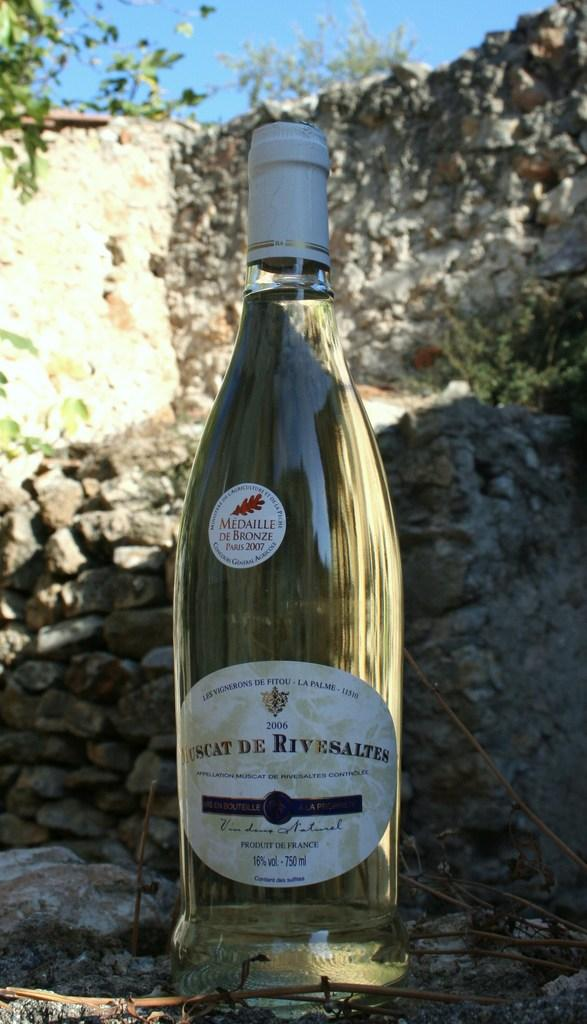What is the main object in the center of the image? There is a wine bottle in the center of the image. Where is the wine bottle located in relation to the other elements in the image? The wine bottle is in the center of the image. What can be seen in the background of the image? There are stones and a tree in the background of the image. What type of test is being conducted with the wine bottle in the image? There is no test being conducted with the wine bottle in the image. The image simply shows a wine bottle in the center with stones and a tree in the background. 